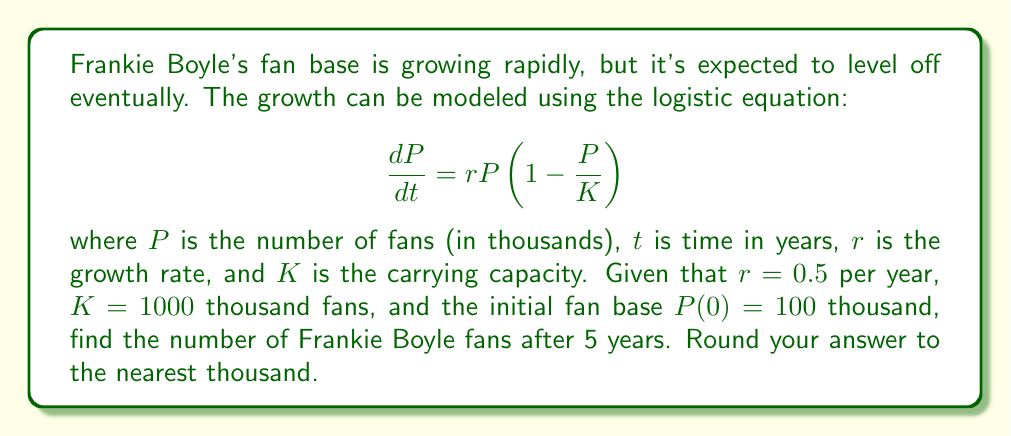Can you solve this math problem? To solve this problem, we need to use the solution to the logistic equation:

$$P(t) = \frac{K}{1 + (\frac{K}{P_0} - 1)e^{-rt}}$$

where $P_0$ is the initial population.

Given:
- $r = 0.5$ per year
- $K = 1000$ thousand fans
- $P_0 = P(0) = 100$ thousand fans
- $t = 5$ years

Let's substitute these values into the equation:

$$P(5) = \frac{1000}{1 + (\frac{1000}{100} - 1)e^{-0.5(5)}}$$

$$= \frac{1000}{1 + (10 - 1)e^{-2.5}}$$

$$= \frac{1000}{1 + 9e^{-2.5}}$$

Now, let's calculate this step by step:

1. Calculate $e^{-2.5}$:
   $e^{-2.5} \approx 0.0821$

2. Multiply by 9:
   $9 \times 0.0821 \approx 0.7389$

3. Add 1:
   $1 + 0.7389 = 1.7389$

4. Divide 1000 by this result:
   $\frac{1000}{1.7389} \approx 574.9$

5. Round to the nearest thousand:
   $575$ thousand fans
Answer: 575 thousand fans 